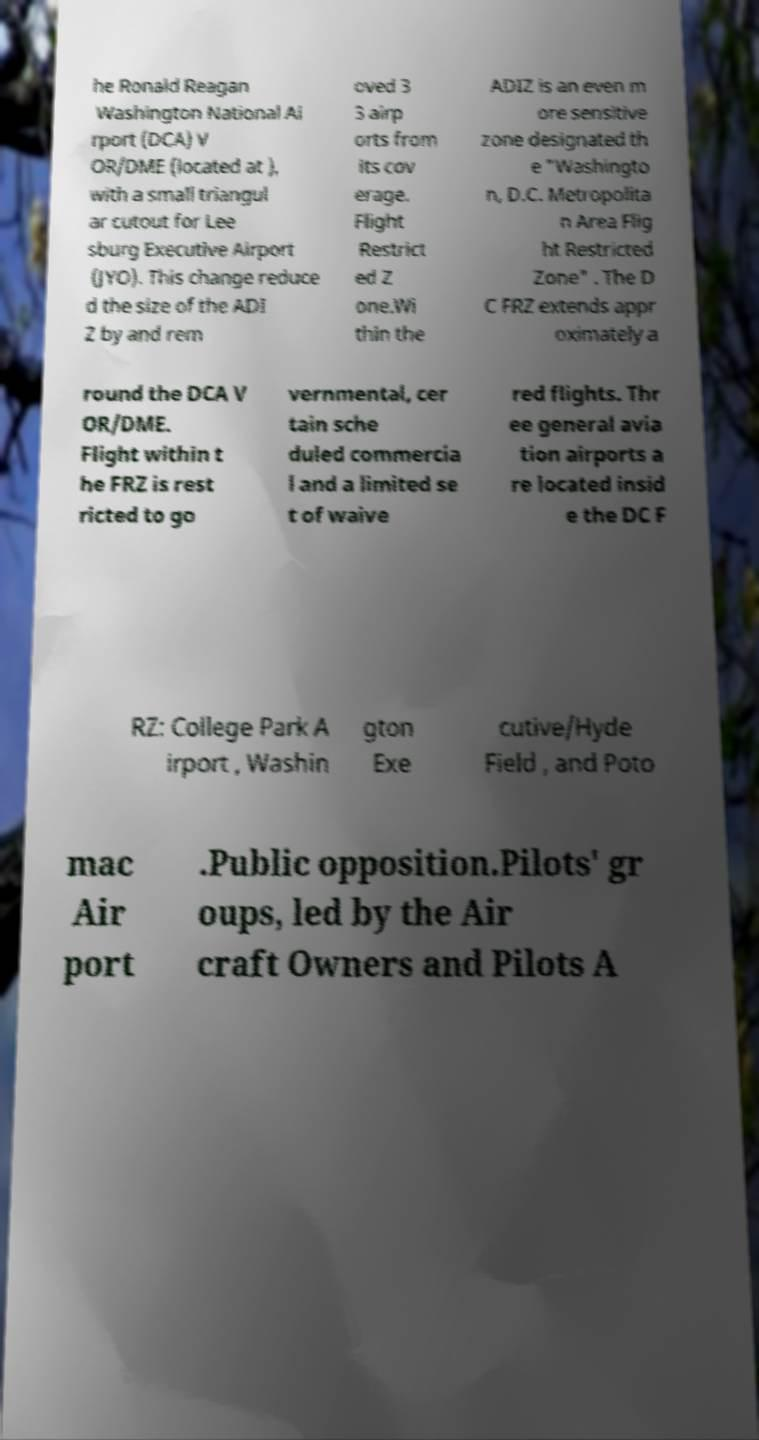For documentation purposes, I need the text within this image transcribed. Could you provide that? he Ronald Reagan Washington National Ai rport (DCA) V OR/DME (located at ), with a small triangul ar cutout for Lee sburg Executive Airport (JYO). This change reduce d the size of the ADI Z by and rem oved 3 3 airp orts from its cov erage. Flight Restrict ed Z one.Wi thin the ADIZ is an even m ore sensitive zone designated th e "Washingto n, D.C. Metropolita n Area Flig ht Restricted Zone" . The D C FRZ extends appr oximately a round the DCA V OR/DME. Flight within t he FRZ is rest ricted to go vernmental, cer tain sche duled commercia l and a limited se t of waive red flights. Thr ee general avia tion airports a re located insid e the DC F RZ: College Park A irport , Washin gton Exe cutive/Hyde Field , and Poto mac Air port .Public opposition.Pilots' gr oups, led by the Air craft Owners and Pilots A 